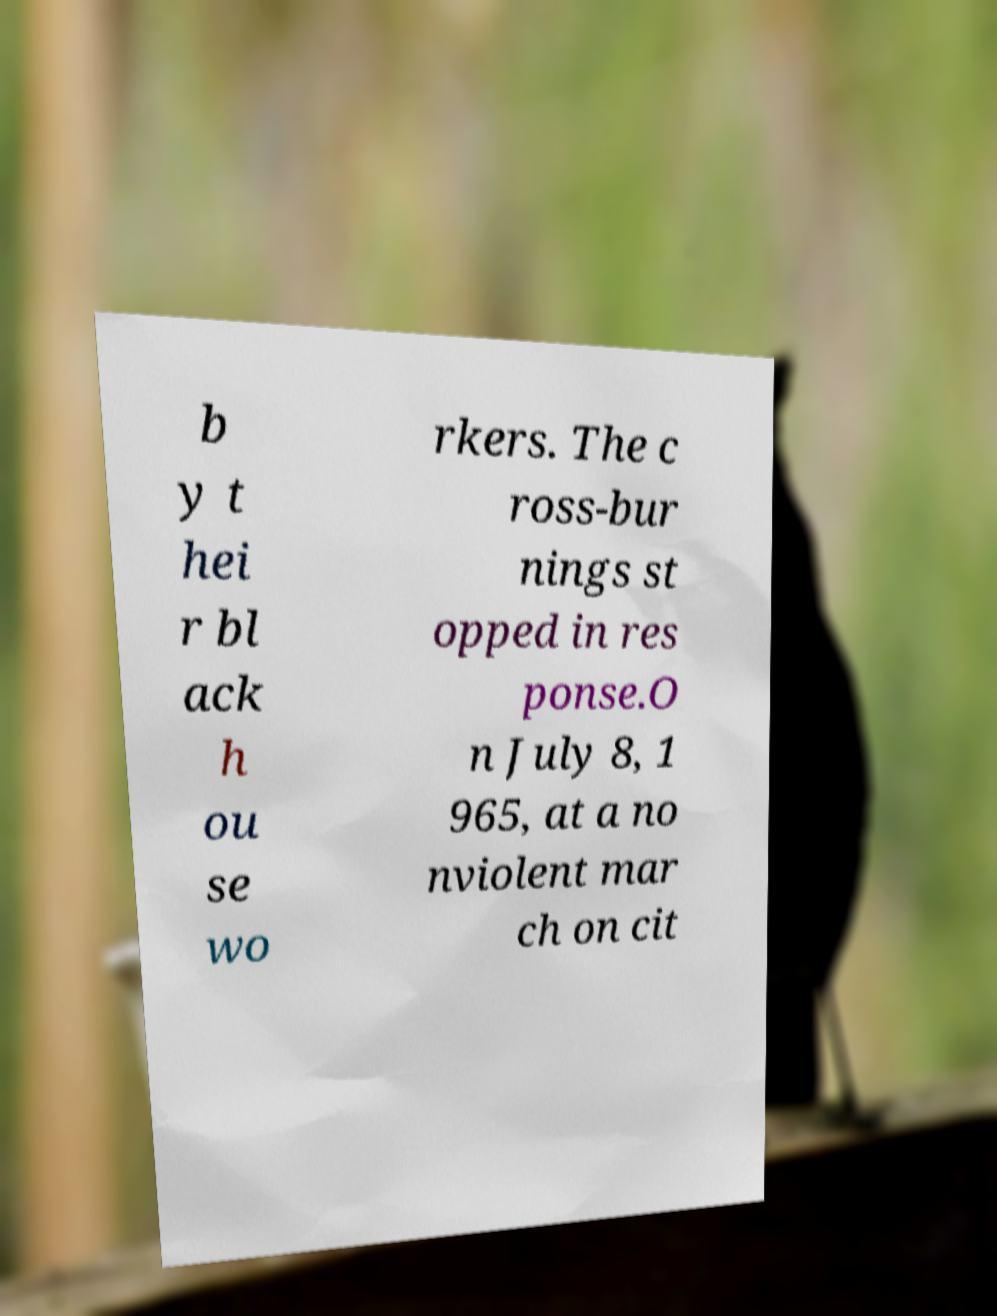What messages or text are displayed in this image? I need them in a readable, typed format. b y t hei r bl ack h ou se wo rkers. The c ross-bur nings st opped in res ponse.O n July 8, 1 965, at a no nviolent mar ch on cit 